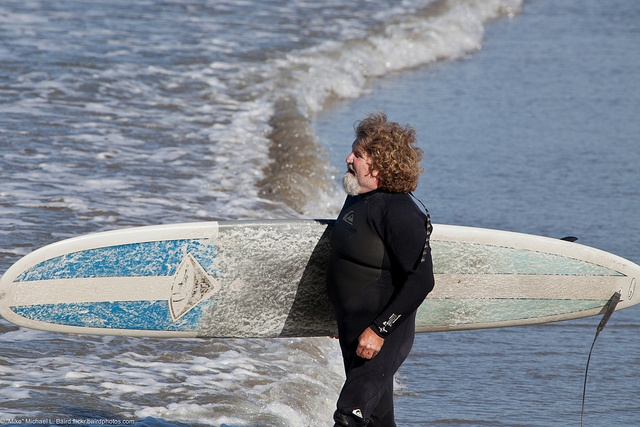Describe the objects in this image and their specific colors. I can see surfboard in gray, darkgray, lightgray, and black tones and people in gray, black, and maroon tones in this image. 